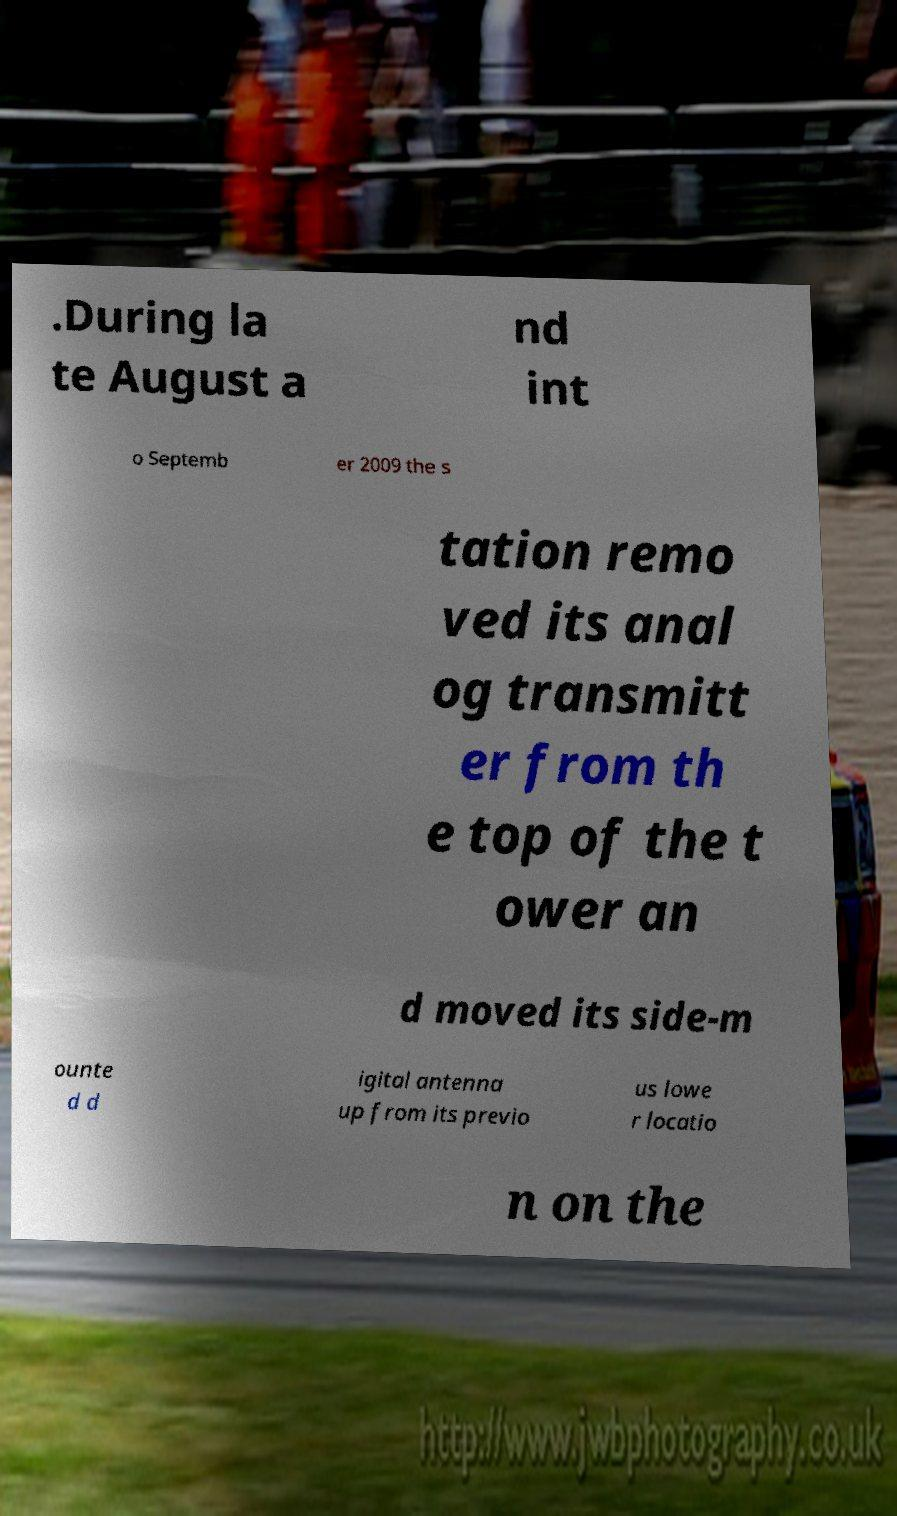Please identify and transcribe the text found in this image. .During la te August a nd int o Septemb er 2009 the s tation remo ved its anal og transmitt er from th e top of the t ower an d moved its side-m ounte d d igital antenna up from its previo us lowe r locatio n on the 